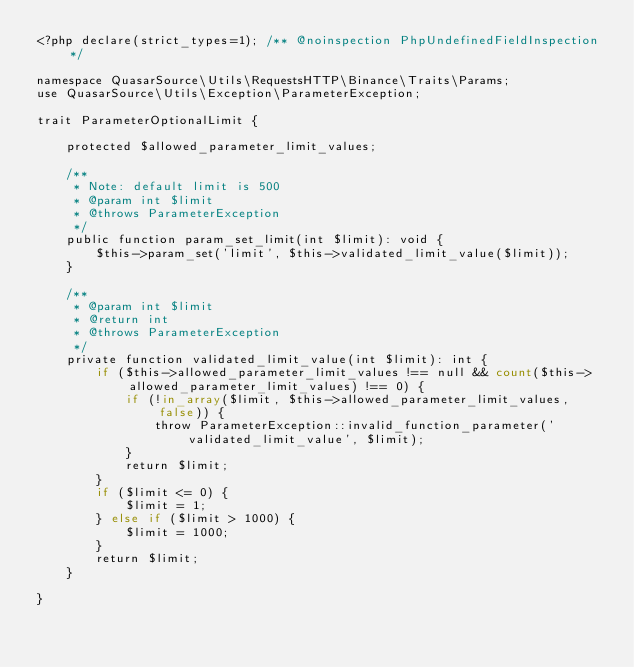<code> <loc_0><loc_0><loc_500><loc_500><_PHP_><?php declare(strict_types=1); /** @noinspection PhpUndefinedFieldInspection */

namespace QuasarSource\Utils\RequestsHTTP\Binance\Traits\Params;
use QuasarSource\Utils\Exception\ParameterException;

trait ParameterOptionalLimit {

    protected $allowed_parameter_limit_values;

    /**
     * Note: default limit is 500
     * @param int $limit
     * @throws ParameterException
     */
    public function param_set_limit(int $limit): void {
        $this->param_set('limit', $this->validated_limit_value($limit));
    }

    /**
     * @param int $limit
     * @return int
     * @throws ParameterException
     */
    private function validated_limit_value(int $limit): int {
        if ($this->allowed_parameter_limit_values !== null && count($this->allowed_parameter_limit_values) !== 0) {
            if (!in_array($limit, $this->allowed_parameter_limit_values, false)) {
                throw ParameterException::invalid_function_parameter('validated_limit_value', $limit);
            }
            return $limit;
        }
        if ($limit <= 0) {
            $limit = 1;
        } else if ($limit > 1000) {
            $limit = 1000;
        }
        return $limit;
    }

}
</code> 